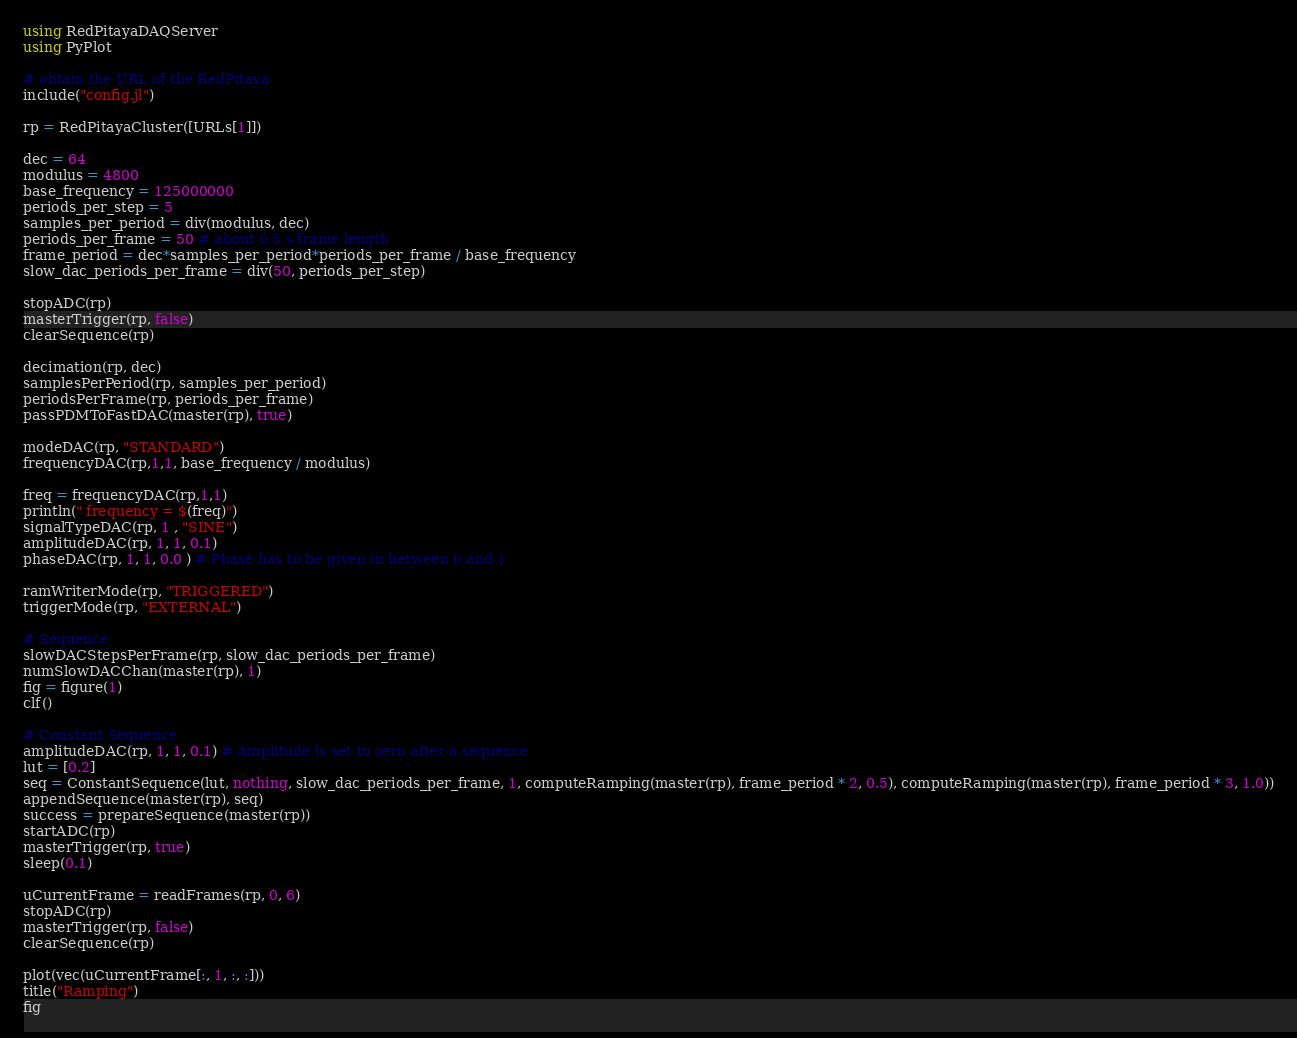<code> <loc_0><loc_0><loc_500><loc_500><_Julia_>using RedPitayaDAQServer
using PyPlot

# obtain the URL of the RedPitaya
include("config.jl")

rp = RedPitayaCluster([URLs[1]])

dec = 64
modulus = 4800
base_frequency = 125000000
periods_per_step = 5
samples_per_period = div(modulus, dec)
periods_per_frame = 50 # about 0.5 s frame length
frame_period = dec*samples_per_period*periods_per_frame / base_frequency
slow_dac_periods_per_frame = div(50, periods_per_step)

stopADC(rp)
masterTrigger(rp, false)
clearSequence(rp)

decimation(rp, dec)
samplesPerPeriod(rp, samples_per_period)
periodsPerFrame(rp, periods_per_frame)
passPDMToFastDAC(master(rp), true)

modeDAC(rp, "STANDARD")
frequencyDAC(rp,1,1, base_frequency / modulus)

freq = frequencyDAC(rp,1,1)
println(" frequency = $(freq)")
signalTypeDAC(rp, 1 , "SINE")
amplitudeDAC(rp, 1, 1, 0.1)
phaseDAC(rp, 1, 1, 0.0 ) # Phase has to be given in between 0 and 1

ramWriterMode(rp, "TRIGGERED")
triggerMode(rp, "EXTERNAL")

# Sequence
slowDACStepsPerFrame(rp, slow_dac_periods_per_frame)
numSlowDACChan(master(rp), 1)
fig = figure(1)
clf()

# Constant Sequence
amplitudeDAC(rp, 1, 1, 0.1) # Amplitude is set to zero after a sequence
lut = [0.2]
seq = ConstantSequence(lut, nothing, slow_dac_periods_per_frame, 1, computeRamping(master(rp), frame_period * 2, 0.5), computeRamping(master(rp), frame_period * 3, 1.0))
appendSequence(master(rp), seq)
success = prepareSequence(master(rp))
startADC(rp)
masterTrigger(rp, true)
sleep(0.1)

uCurrentFrame = readFrames(rp, 0, 6)
stopADC(rp)
masterTrigger(rp, false)
clearSequence(rp)

plot(vec(uCurrentFrame[:, 1, :, :]))
title("Ramping")
fig</code> 